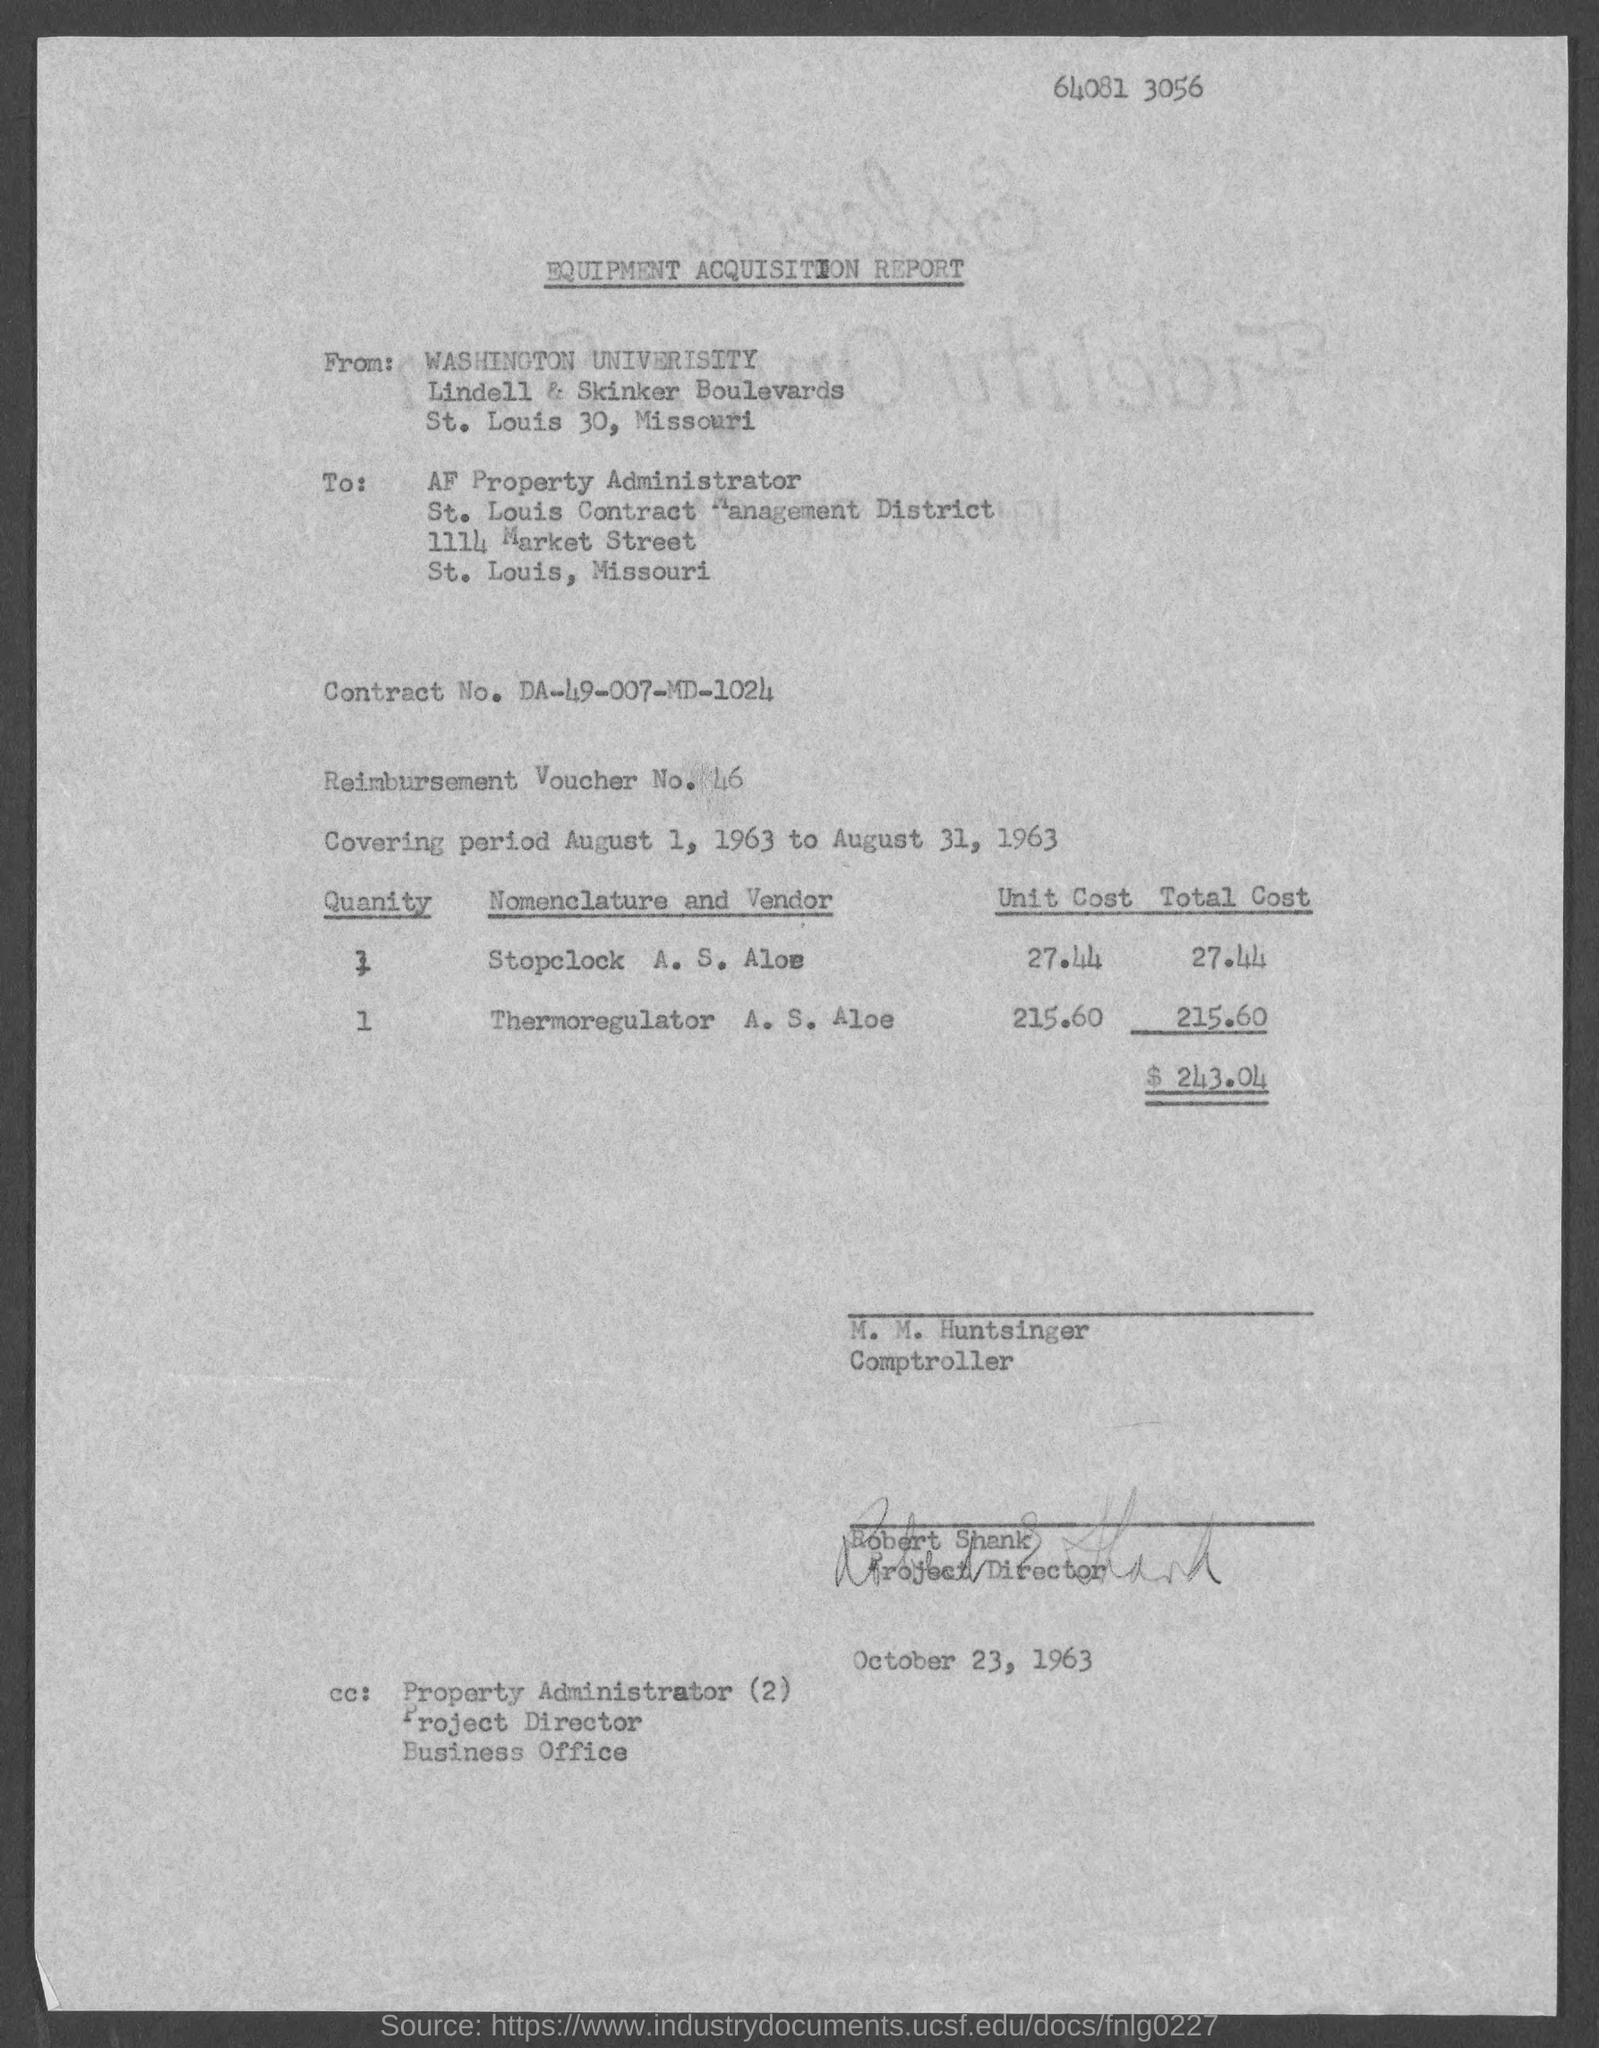What is the contract no mentioned in the Equipment Acquisition Report?
Make the answer very short. DA-49-007-MD-1024. What is the Reimbursement Voucher No. given in the Equipment Acquisition Report?
Your response must be concise. 46. What is the covering period mentioned in the Equipment Acquisition Report?
Offer a terse response. Covering period August 1, 1963 to August 31, 1963. Who has signed the Equipment Acquisition Report?
Your answer should be very brief. Robert Shank. What is the unit cost for Thermoregulator as per the Equipment Acquisition Report?
Your answer should be very brief. $ 215.60. What is the unit cost for Stoplock as per the Equipment Acquisition Report?
Your answer should be very brief. $ 27.44. 